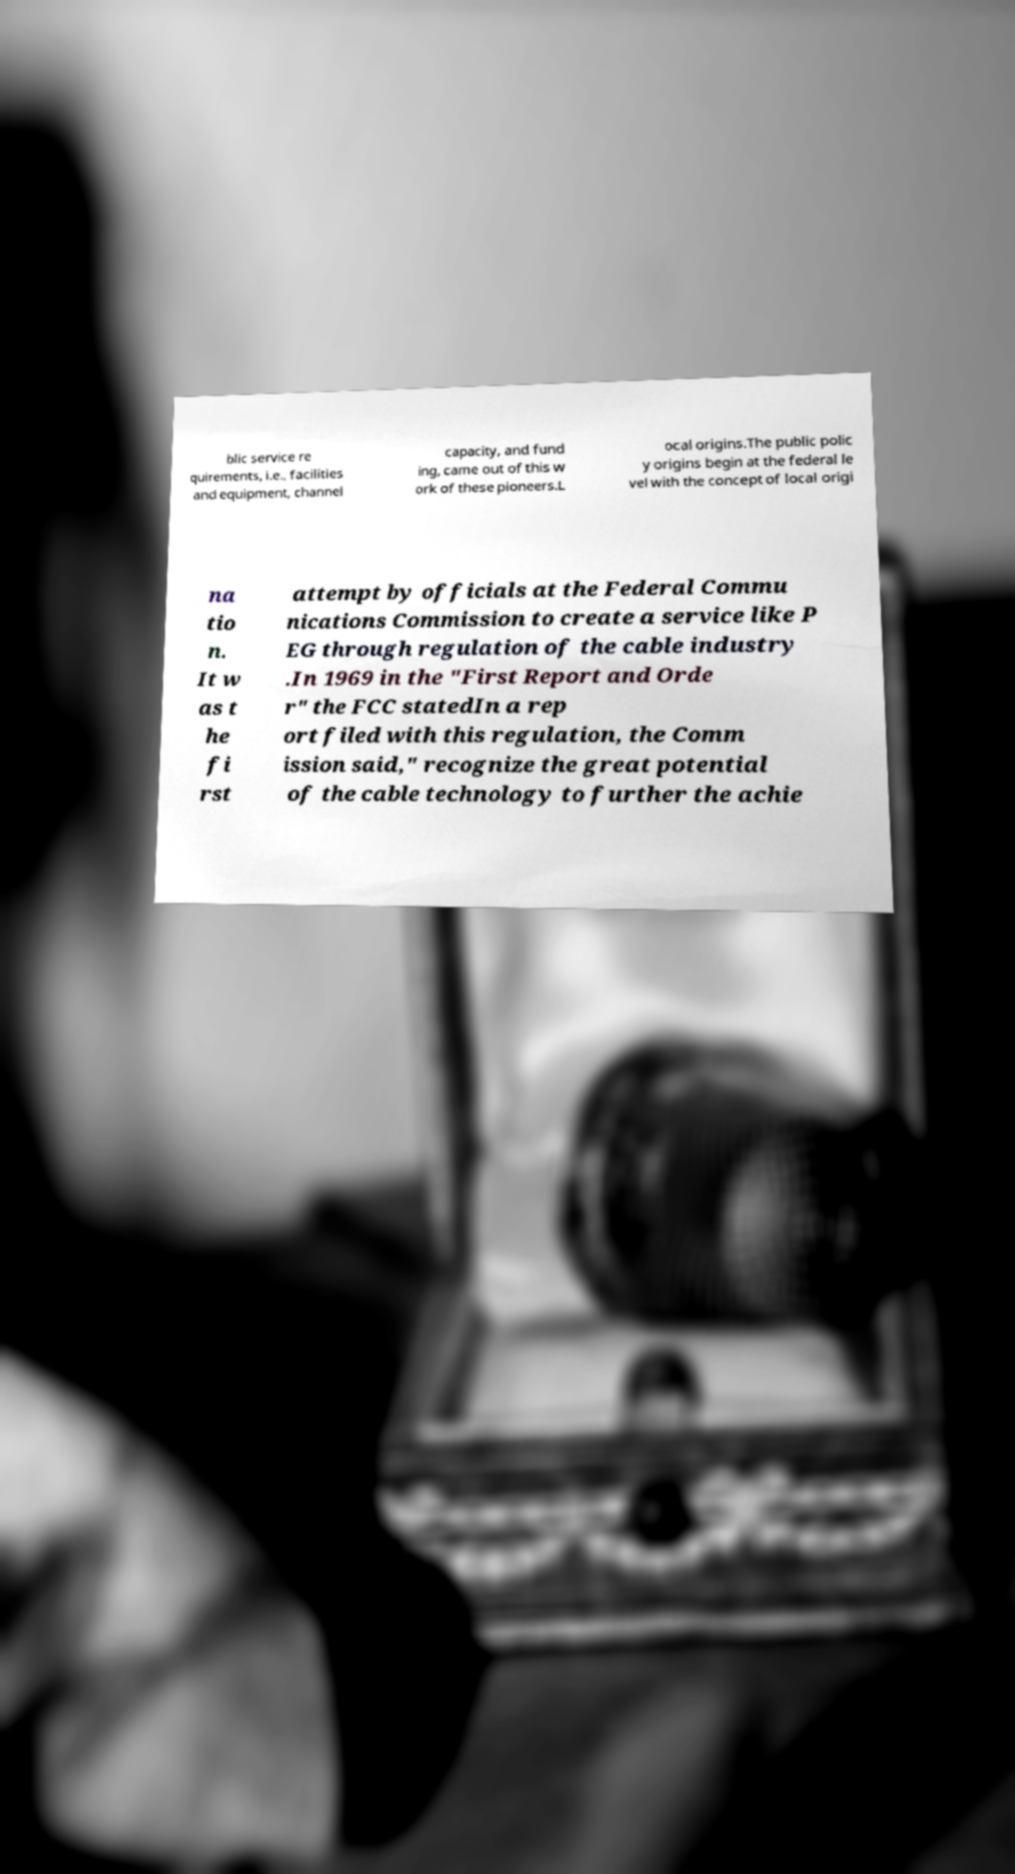Please identify and transcribe the text found in this image. blic service re quirements, i.e., facilities and equipment, channel capacity, and fund ing, came out of this w ork of these pioneers.L ocal origins.The public polic y origins begin at the federal le vel with the concept of local origi na tio n. It w as t he fi rst attempt by officials at the Federal Commu nications Commission to create a service like P EG through regulation of the cable industry .In 1969 in the "First Report and Orde r" the FCC statedIn a rep ort filed with this regulation, the Comm ission said," recognize the great potential of the cable technology to further the achie 